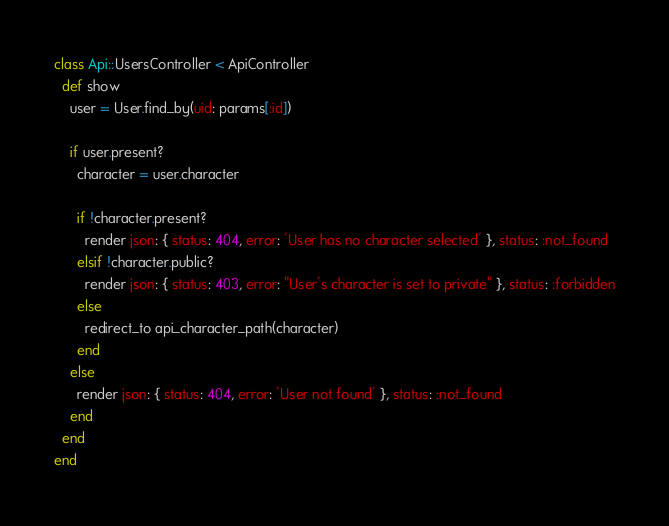<code> <loc_0><loc_0><loc_500><loc_500><_Ruby_>class Api::UsersController < ApiController
  def show
    user = User.find_by(uid: params[:id])

    if user.present?
      character = user.character

      if !character.present?
        render json: { status: 404, error: 'User has no character selected' }, status: :not_found
      elsif !character.public?
        render json: { status: 403, error: "User's character is set to private" }, status: :forbidden
      else
        redirect_to api_character_path(character)
      end
    else
      render json: { status: 404, error: 'User not found' }, status: :not_found
    end
  end
end
</code> 